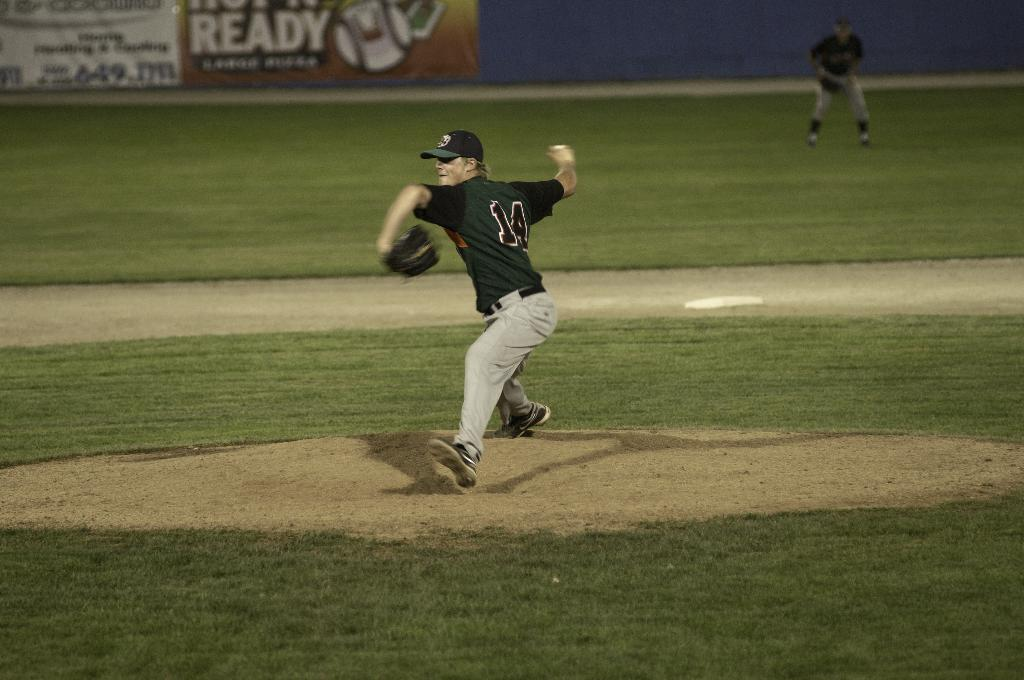<image>
Render a clear and concise summary of the photo. An athlete prepares to throw a baseball in a black jersey with the number 14 on it. 